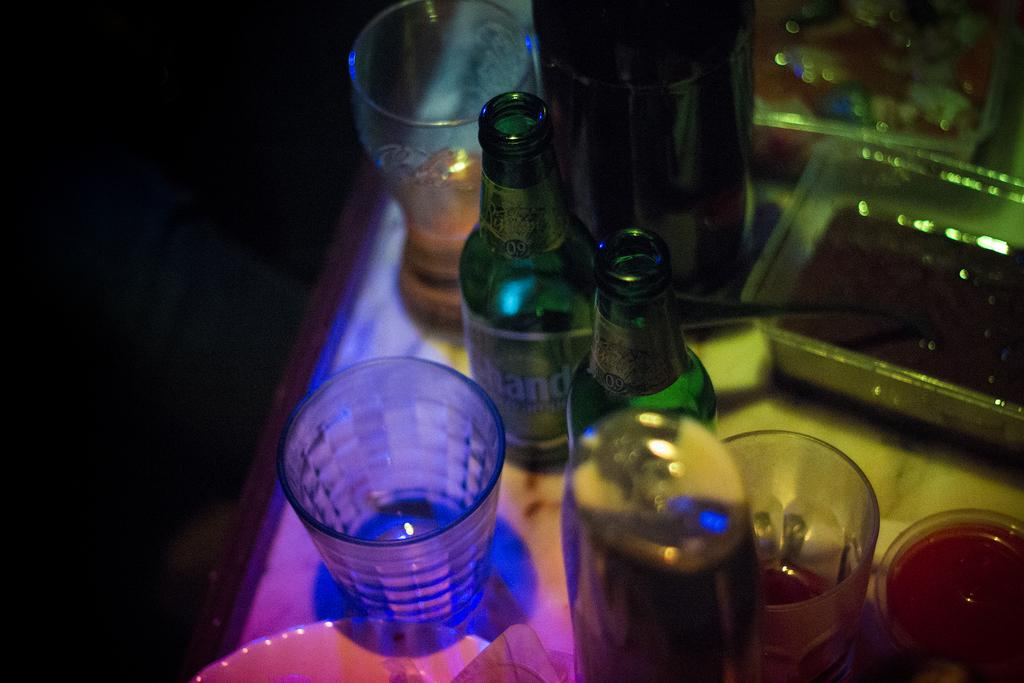Provide a one-sentence caption for the provided image. a dark bar table shows glasses and bottles with letters HAND on it. 